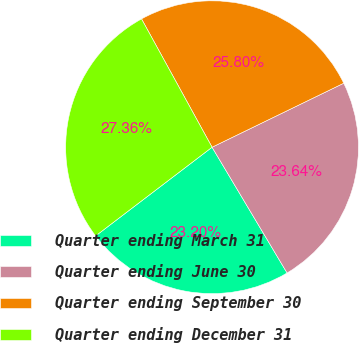Convert chart to OTSL. <chart><loc_0><loc_0><loc_500><loc_500><pie_chart><fcel>Quarter ending March 31<fcel>Quarter ending June 30<fcel>Quarter ending September 30<fcel>Quarter ending December 31<nl><fcel>23.2%<fcel>23.64%<fcel>25.8%<fcel>27.36%<nl></chart> 